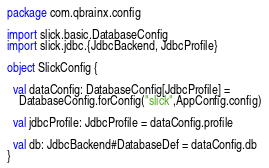<code> <loc_0><loc_0><loc_500><loc_500><_Scala_>package com.qbrainx.config

import slick.basic.DatabaseConfig
import slick.jdbc.{JdbcBackend, JdbcProfile}

object SlickConfig {

  val dataConfig: DatabaseConfig[JdbcProfile] =
    DatabaseConfig.forConfig("slick",AppConfig.config)

  val jdbcProfile: JdbcProfile = dataConfig.profile

  val db: JdbcBackend#DatabaseDef = dataConfig.db
}

</code> 